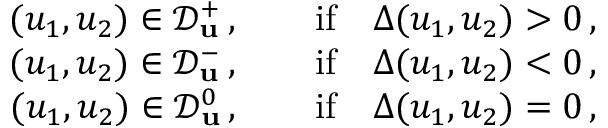<formula> <loc_0><loc_0><loc_500><loc_500>\begin{array} { r } { ( u _ { 1 } , u _ { 2 } ) \in \mathcal { D } _ { u } ^ { + } \, , \quad i f \quad \Delta ( u _ { 1 } , u _ { 2 } ) > 0 \, , } \\ { ( u _ { 1 } , u _ { 2 } ) \in \mathcal { D } _ { u } ^ { - } \, , \quad i f \quad \Delta ( u _ { 1 } , u _ { 2 } ) < 0 \, , } \\ { ( u _ { 1 } , u _ { 2 } ) \in \mathcal { D } _ { u } ^ { 0 } \, , \quad i f \quad \Delta ( u _ { 1 } , u _ { 2 } ) = 0 \, , } \end{array}</formula> 